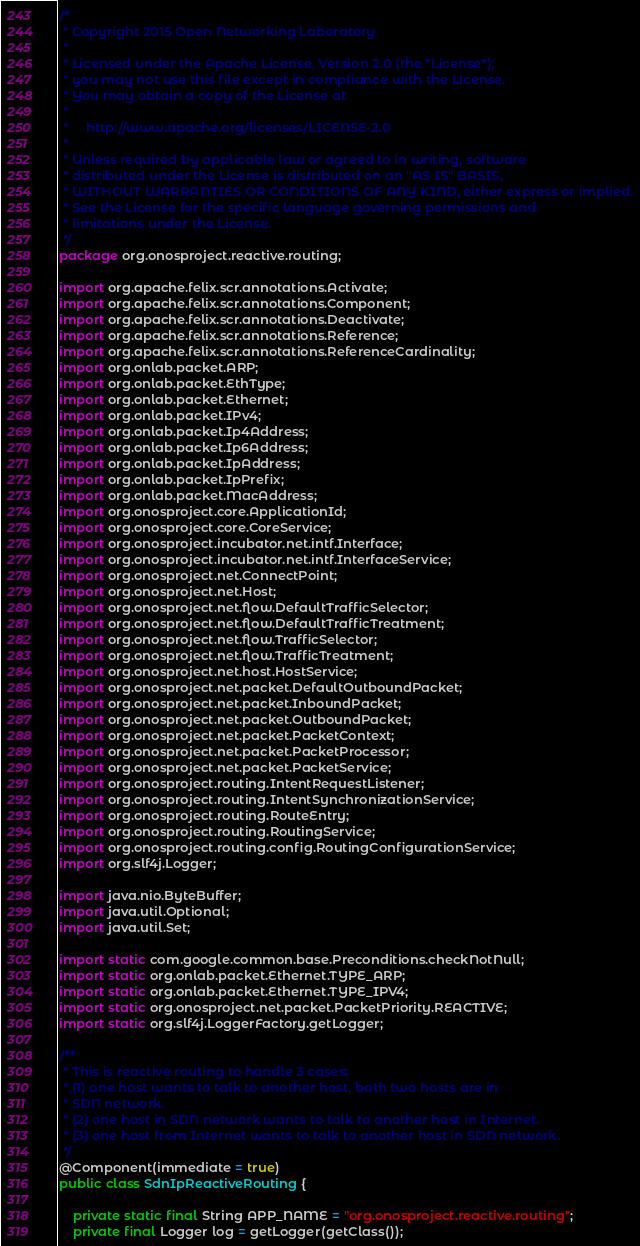<code> <loc_0><loc_0><loc_500><loc_500><_Java_>/*
 * Copyright 2015 Open Networking Laboratory
 *
 * Licensed under the Apache License, Version 2.0 (the "License");
 * you may not use this file except in compliance with the License.
 * You may obtain a copy of the License at
 *
 *     http://www.apache.org/licenses/LICENSE-2.0
 *
 * Unless required by applicable law or agreed to in writing, software
 * distributed under the License is distributed on an "AS IS" BASIS,
 * WITHOUT WARRANTIES OR CONDITIONS OF ANY KIND, either express or implied.
 * See the License for the specific language governing permissions and
 * limitations under the License.
 */
package org.onosproject.reactive.routing;

import org.apache.felix.scr.annotations.Activate;
import org.apache.felix.scr.annotations.Component;
import org.apache.felix.scr.annotations.Deactivate;
import org.apache.felix.scr.annotations.Reference;
import org.apache.felix.scr.annotations.ReferenceCardinality;
import org.onlab.packet.ARP;
import org.onlab.packet.EthType;
import org.onlab.packet.Ethernet;
import org.onlab.packet.IPv4;
import org.onlab.packet.Ip4Address;
import org.onlab.packet.Ip6Address;
import org.onlab.packet.IpAddress;
import org.onlab.packet.IpPrefix;
import org.onlab.packet.MacAddress;
import org.onosproject.core.ApplicationId;
import org.onosproject.core.CoreService;
import org.onosproject.incubator.net.intf.Interface;
import org.onosproject.incubator.net.intf.InterfaceService;
import org.onosproject.net.ConnectPoint;
import org.onosproject.net.Host;
import org.onosproject.net.flow.DefaultTrafficSelector;
import org.onosproject.net.flow.DefaultTrafficTreatment;
import org.onosproject.net.flow.TrafficSelector;
import org.onosproject.net.flow.TrafficTreatment;
import org.onosproject.net.host.HostService;
import org.onosproject.net.packet.DefaultOutboundPacket;
import org.onosproject.net.packet.InboundPacket;
import org.onosproject.net.packet.OutboundPacket;
import org.onosproject.net.packet.PacketContext;
import org.onosproject.net.packet.PacketProcessor;
import org.onosproject.net.packet.PacketService;
import org.onosproject.routing.IntentRequestListener;
import org.onosproject.routing.IntentSynchronizationService;
import org.onosproject.routing.RouteEntry;
import org.onosproject.routing.RoutingService;
import org.onosproject.routing.config.RoutingConfigurationService;
import org.slf4j.Logger;

import java.nio.ByteBuffer;
import java.util.Optional;
import java.util.Set;

import static com.google.common.base.Preconditions.checkNotNull;
import static org.onlab.packet.Ethernet.TYPE_ARP;
import static org.onlab.packet.Ethernet.TYPE_IPV4;
import static org.onosproject.net.packet.PacketPriority.REACTIVE;
import static org.slf4j.LoggerFactory.getLogger;

/**
 * This is reactive routing to handle 3 cases:
 * (1) one host wants to talk to another host, both two hosts are in
 * SDN network.
 * (2) one host in SDN network wants to talk to another host in Internet.
 * (3) one host from Internet wants to talk to another host in SDN network.
 */
@Component(immediate = true)
public class SdnIpReactiveRouting {

    private static final String APP_NAME = "org.onosproject.reactive.routing";
    private final Logger log = getLogger(getClass());
</code> 